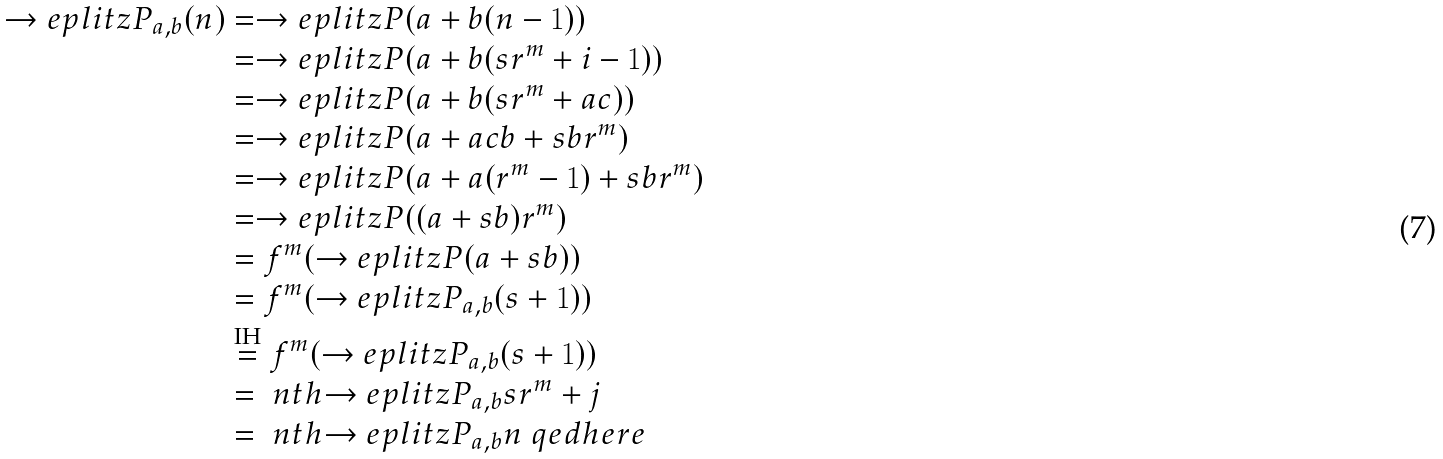<formula> <loc_0><loc_0><loc_500><loc_500>\to e p l i t z { P } _ { a , b } ( n ) & = \to e p l i t z { P } ( a + b ( n - 1 ) ) \\ & = \to e p l i t z { P } ( a + b ( s r ^ { m } + i - 1 ) ) \\ & = \to e p l i t z { P } ( a + b ( s r ^ { m } + a c ) ) \\ & = \to e p l i t z { P } ( a + a c b + s b r ^ { m } ) \\ & = \to e p l i t z { P } ( a + a ( r ^ { m } - 1 ) + s b r ^ { m } ) \\ & = \to e p l i t z { P } ( ( a + s b ) r ^ { m } ) \\ & = f ^ { m } ( \to e p l i t z { P } ( a + s b ) ) \\ & = f ^ { m } ( \to e p l i t z { P } _ { a , b } ( s + 1 ) ) \\ & \stackrel { \text {IH} } { = } f ^ { m } ( \to e p l i t z { P _ { a , b } } ( s + 1 ) ) \\ & = \ n t h { \to e p l i t z { P _ { a , b } } } { s r ^ { m } + j } \\ & = \ n t h { \to e p l i t z { P _ { a , b } } } { n } \ q e d h e r e</formula> 